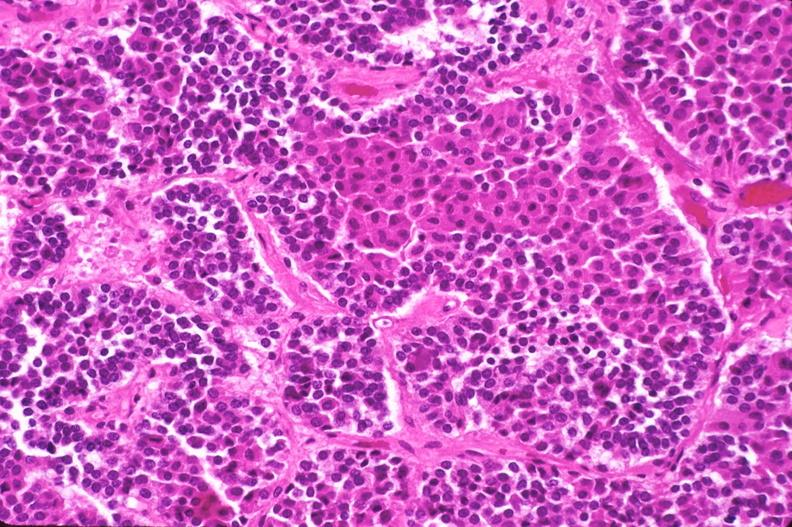does this image show pituitary, chromaphobe adenoma?
Answer the question using a single word or phrase. Yes 